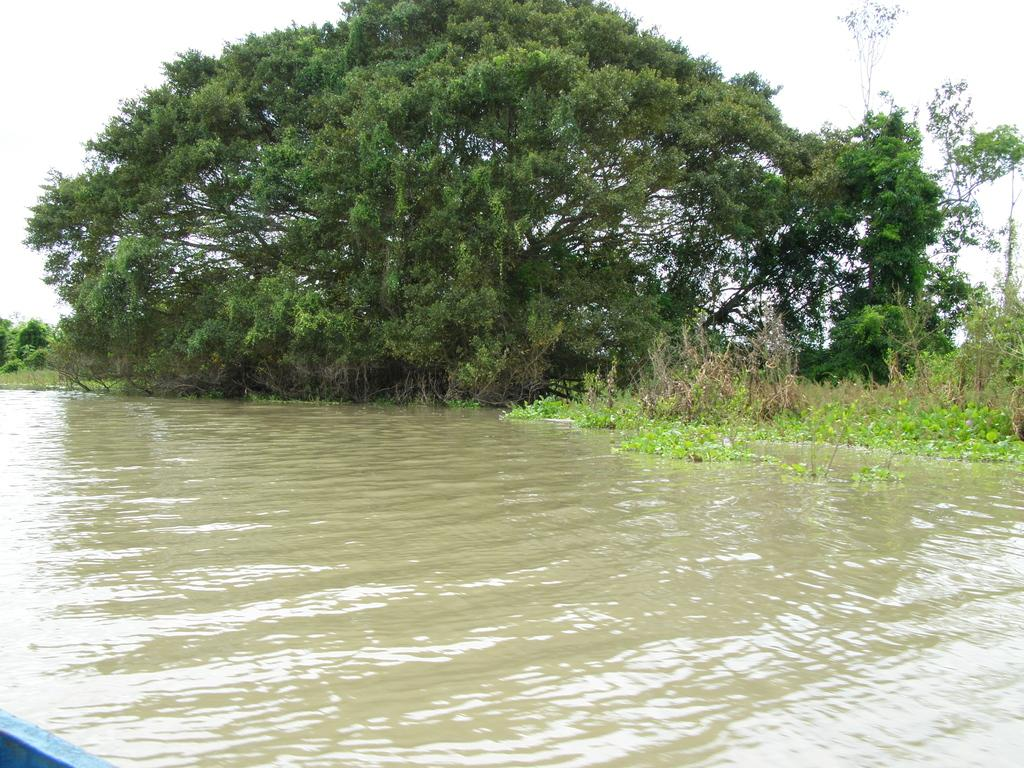What is present in the front of the image? There is water in the front of the image. What can be seen in the background of the image? There is grass, trees, and the sky visible in the background of the image. Can you describe the color of the thing in the bottom left corner of the image? There is a blue color thing in the bottom left corner of the image. What type of carpenter tool is being used in the image? There is no carpenter tool present in the image. What flavor of soda can be seen in the image? There is no soda present in the image. 